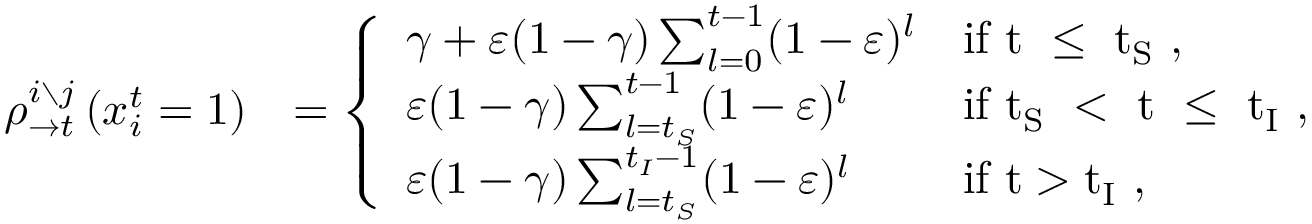<formula> <loc_0><loc_0><loc_500><loc_500>\begin{array} { r l } { \rho _ { \rightarrow t } ^ { i \ j } \left ( x _ { i } ^ { t } = 1 \right ) } & { = \left \{ \begin{array} { l l } { \gamma + \varepsilon ( 1 - \gamma ) \sum _ { l = 0 } ^ { t - 1 } ( 1 - \varepsilon ) ^ { l } } & { i f t \leq t _ { S } , } \\ { \varepsilon ( 1 - \gamma ) \sum _ { l = t _ { S } } ^ { t - 1 } ( 1 - \varepsilon ) ^ { l } } & { i f t _ { S } < t \leq t _ { I } , } \\ { \varepsilon ( 1 - \gamma ) \sum _ { l = t _ { S } } ^ { t _ { I } - 1 } ( 1 - \varepsilon ) ^ { l } } & { i f t > t _ { I } , } \end{array} } \end{array}</formula> 